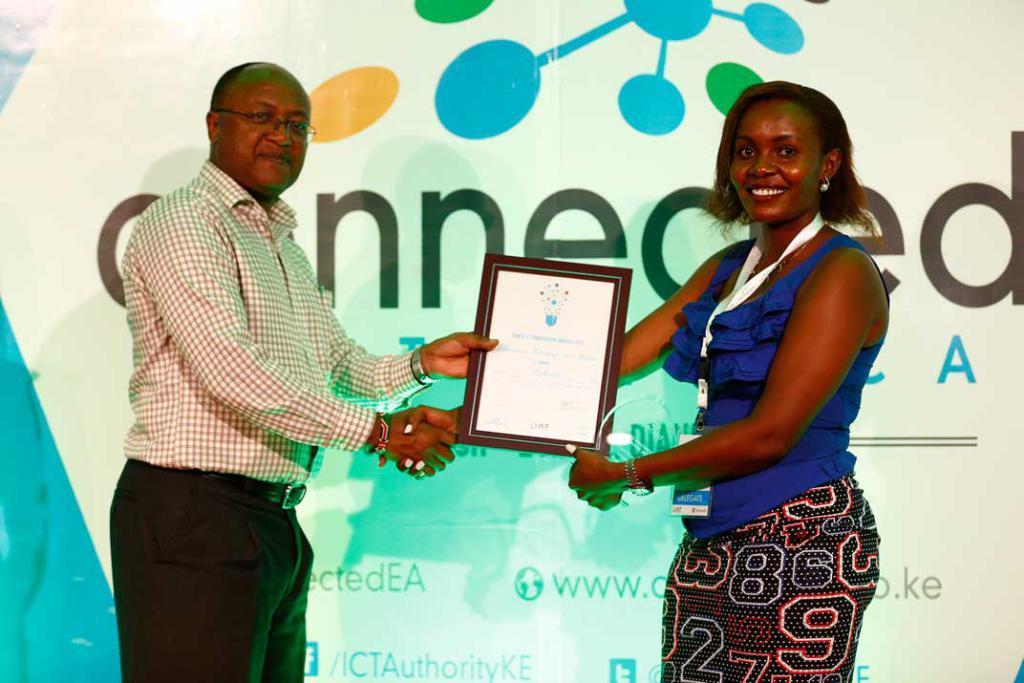Describe this image in one or two sentences. In this image in front there are two people shaking their hands and there are holding a photo frame. Behind them there is a banner. 